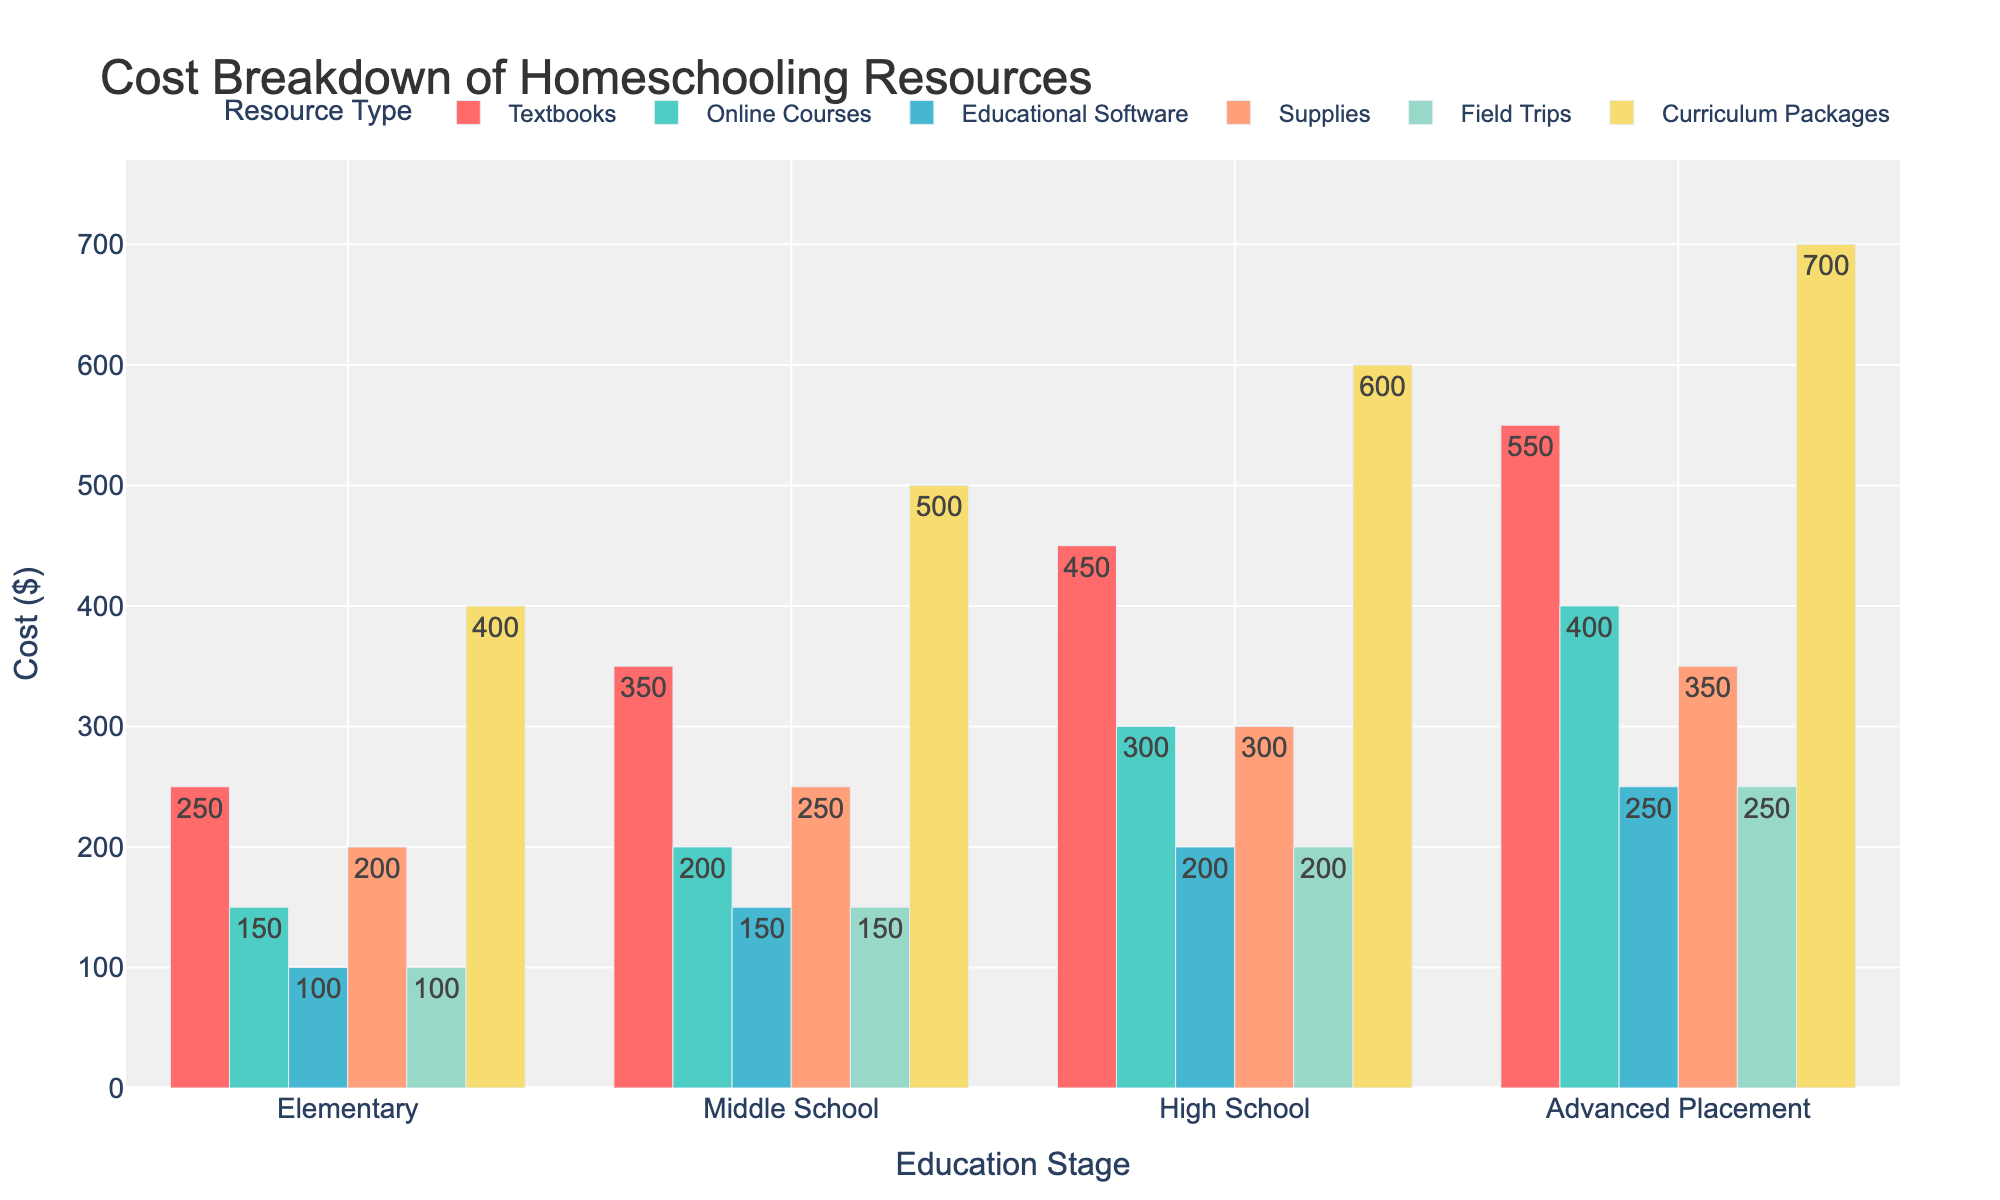What's the title of the figure? The title is prominently displayed at the top of the figure. It reads "Monthly Cybersecurity Incident Rates for Canadian Financial Institutions."
Answer: Monthly Cybersecurity Incident Rates for Canadian Financial Institutions What is the incident rate for TD Bank in August? The TD Bank's plot for August shows a value next to the corresponding marker.
Answer: 16 Which bank had the highest incident rate in December? Look at the plots in December for all banks. RBC has the highest rate.
Answer: RBC What is the overall trend for BMO's incident rates from January to December? BMO's incident rates gradually increase each month as indicated by an upward trend in the plot from January to December.
Answer: Increasing How does Scotiabank's incident rate in June compare to November? Compare the markers for Scotiabank in both June and November. It was 12 in June and 17 in November.
Answer: It increased What is the average incident rate for RBC from January to December? Sum RBC's monthly incident rates and divide by the number of months (12). (12 + 15 + 14 + 13 + 16 + 18 + 17 + 19 + 21 + 20 + 22 + 23)/12 = 190/12
Answer: 15.83 Which two months show the highest increase in incident rates for CIBC? Check the steepest rise between consecutive months in CIBC's plot. The increases from May to June (14 to 16) and September to October (19 to 21) are highest.
Answer: May to June, September to October What is the range of incident rates for RBC throughout the year? Calculate the difference between RBC's maximum (23) and minimum (12) incident rates.
Answer: 11 In which month do all banks generally show a peak in incident rates? Look for a month where all plots show a peak or near-peak incident rates. November stands out.
Answer: November Arrange the banks in descending order of their incident rates in March. Compare the March incident rates for all banks. RBC (14), CIBC (12), BMO (11), Scotiabank (10), and TD Bank (9).
Answer: RBC, CIBC, BMO, Scotiabank, TD Bank 